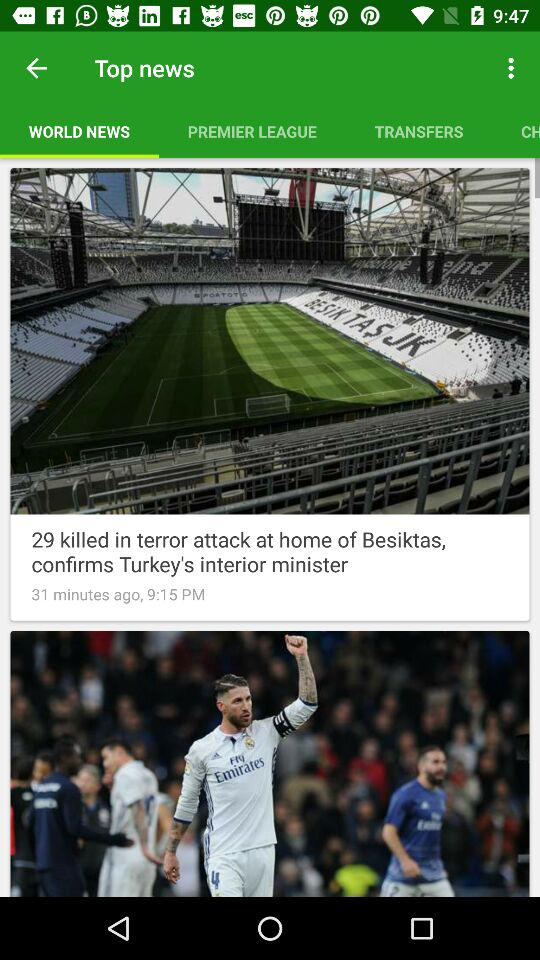How many minutes ago was the "29 killed in terror attack" posted? It was posted 31 minutes ago. 